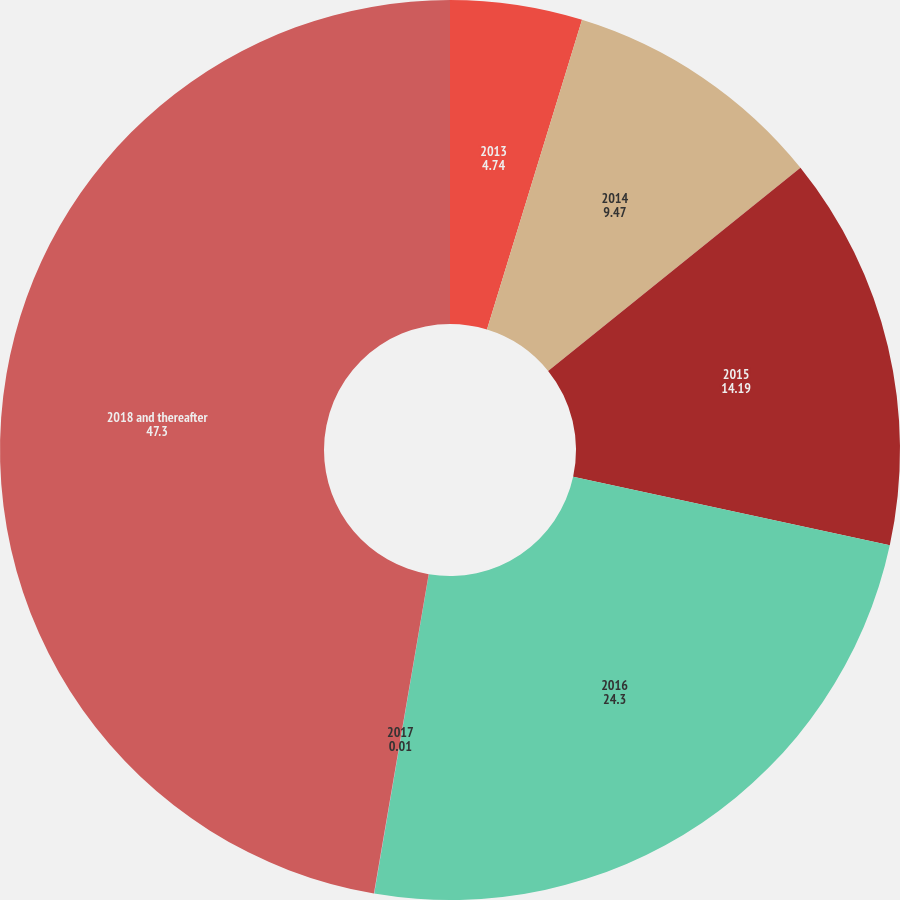<chart> <loc_0><loc_0><loc_500><loc_500><pie_chart><fcel>2013<fcel>2014<fcel>2015<fcel>2016<fcel>2017<fcel>2018 and thereafter<nl><fcel>4.74%<fcel>9.47%<fcel>14.19%<fcel>24.3%<fcel>0.01%<fcel>47.3%<nl></chart> 